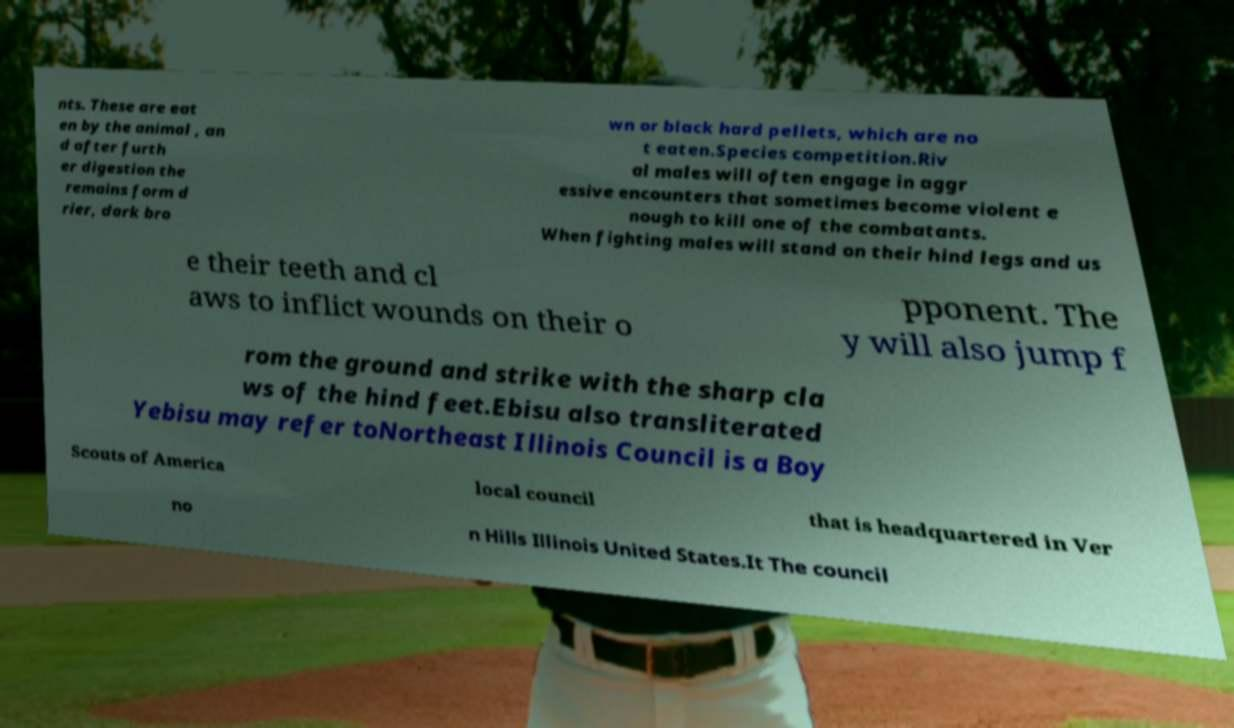Please read and relay the text visible in this image. What does it say? nts. These are eat en by the animal , an d after furth er digestion the remains form d rier, dark bro wn or black hard pellets, which are no t eaten.Species competition.Riv al males will often engage in aggr essive encounters that sometimes become violent e nough to kill one of the combatants. When fighting males will stand on their hind legs and us e their teeth and cl aws to inflict wounds on their o pponent. The y will also jump f rom the ground and strike with the sharp cla ws of the hind feet.Ebisu also transliterated Yebisu may refer toNortheast Illinois Council is a Boy Scouts of America local council that is headquartered in Ver no n Hills Illinois United States.It The council 